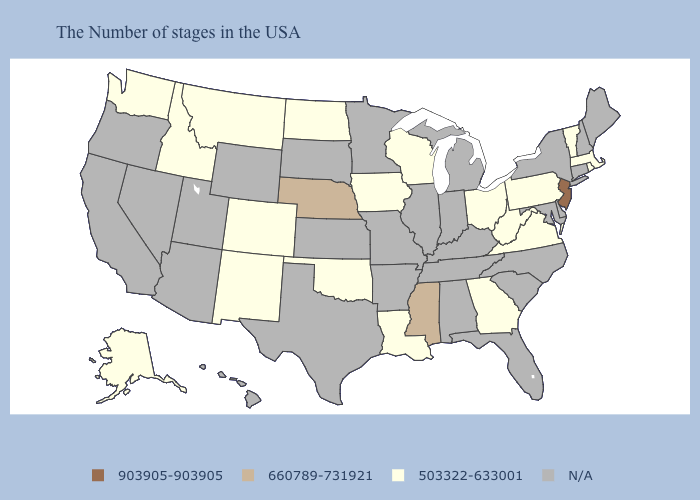Which states hav the highest value in the Northeast?
Concise answer only. New Jersey. What is the lowest value in states that border Ohio?
Short answer required. 503322-633001. Which states have the highest value in the USA?
Write a very short answer. New Jersey. Name the states that have a value in the range 660789-731921?
Concise answer only. Mississippi, Nebraska. Which states have the highest value in the USA?
Short answer required. New Jersey. What is the value of New Hampshire?
Quick response, please. N/A. Which states hav the highest value in the Northeast?
Short answer required. New Jersey. Does Wisconsin have the highest value in the MidWest?
Answer briefly. No. What is the value of Louisiana?
Answer briefly. 503322-633001. What is the highest value in the MidWest ?
Concise answer only. 660789-731921. Name the states that have a value in the range 503322-633001?
Short answer required. Massachusetts, Rhode Island, Vermont, Pennsylvania, Virginia, West Virginia, Ohio, Georgia, Wisconsin, Louisiana, Iowa, Oklahoma, North Dakota, Colorado, New Mexico, Montana, Idaho, Washington, Alaska. Name the states that have a value in the range 660789-731921?
Write a very short answer. Mississippi, Nebraska. Which states have the highest value in the USA?
Be succinct. New Jersey. Name the states that have a value in the range 903905-903905?
Quick response, please. New Jersey. 